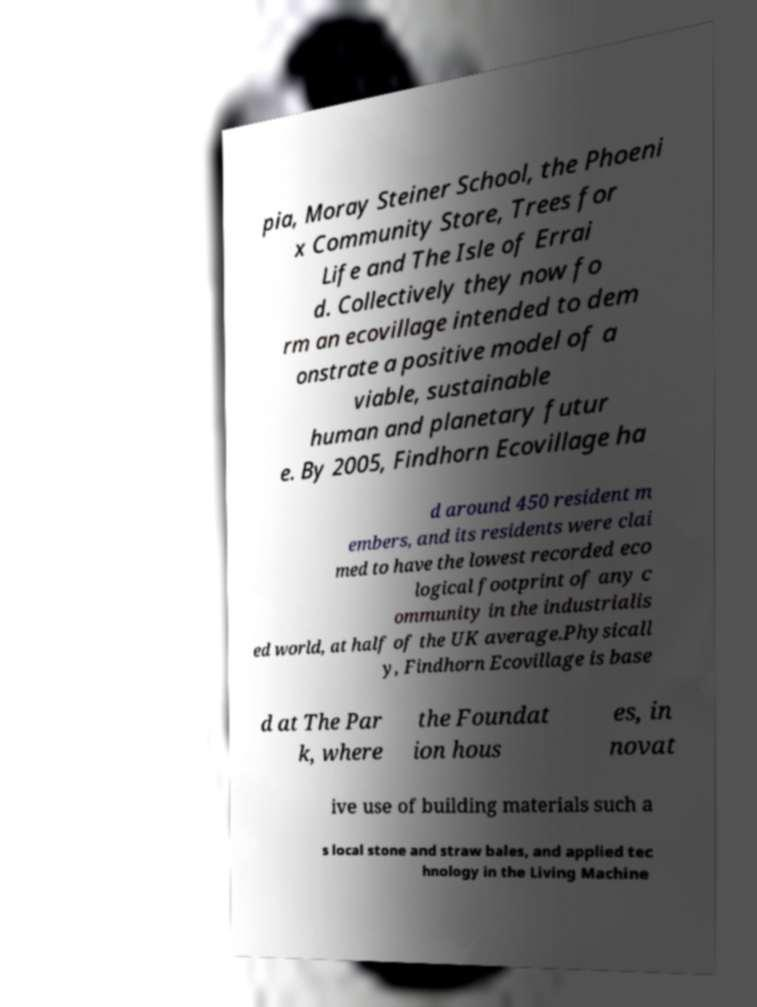Please read and relay the text visible in this image. What does it say? pia, Moray Steiner School, the Phoeni x Community Store, Trees for Life and The Isle of Errai d. Collectively they now fo rm an ecovillage intended to dem onstrate a positive model of a viable, sustainable human and planetary futur e. By 2005, Findhorn Ecovillage ha d around 450 resident m embers, and its residents were clai med to have the lowest recorded eco logical footprint of any c ommunity in the industrialis ed world, at half of the UK average.Physicall y, Findhorn Ecovillage is base d at The Par k, where the Foundat ion hous es, in novat ive use of building materials such a s local stone and straw bales, and applied tec hnology in the Living Machine 